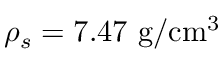Convert formula to latex. <formula><loc_0><loc_0><loc_500><loc_500>\rho _ { s } = 7 . 4 7 g / c m ^ { 3 }</formula> 